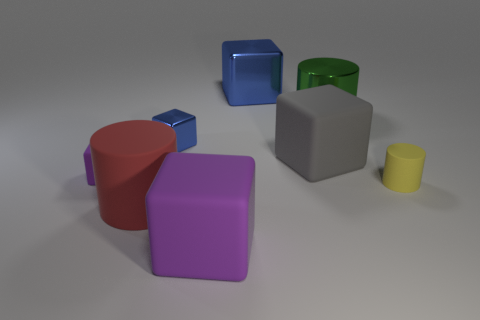What is the shape of the thing that is the same color as the tiny shiny block?
Keep it short and to the point. Cube. What is the shape of the red object that is the same size as the green metallic object?
Offer a terse response. Cylinder. There is a tiny thing on the left side of the metallic object to the left of the cube behind the tiny blue metallic block; what is its color?
Offer a terse response. Purple. Does the large green thing have the same shape as the small yellow thing?
Offer a terse response. Yes. Are there an equal number of large purple things that are to the left of the large green metal cylinder and yellow cylinders?
Keep it short and to the point. Yes. How many other things are the same material as the gray thing?
Offer a very short reply. 4. There is a gray matte block behind the red matte cylinder; is its size the same as the purple thing on the left side of the tiny blue object?
Your answer should be compact. No. How many objects are large blocks behind the gray block or big things in front of the small metal object?
Provide a short and direct response. 4. Is the color of the big metal object behind the large green metal thing the same as the small cube that is behind the small purple thing?
Provide a short and direct response. Yes. How many matte things are either large green cylinders or small gray blocks?
Keep it short and to the point. 0. 